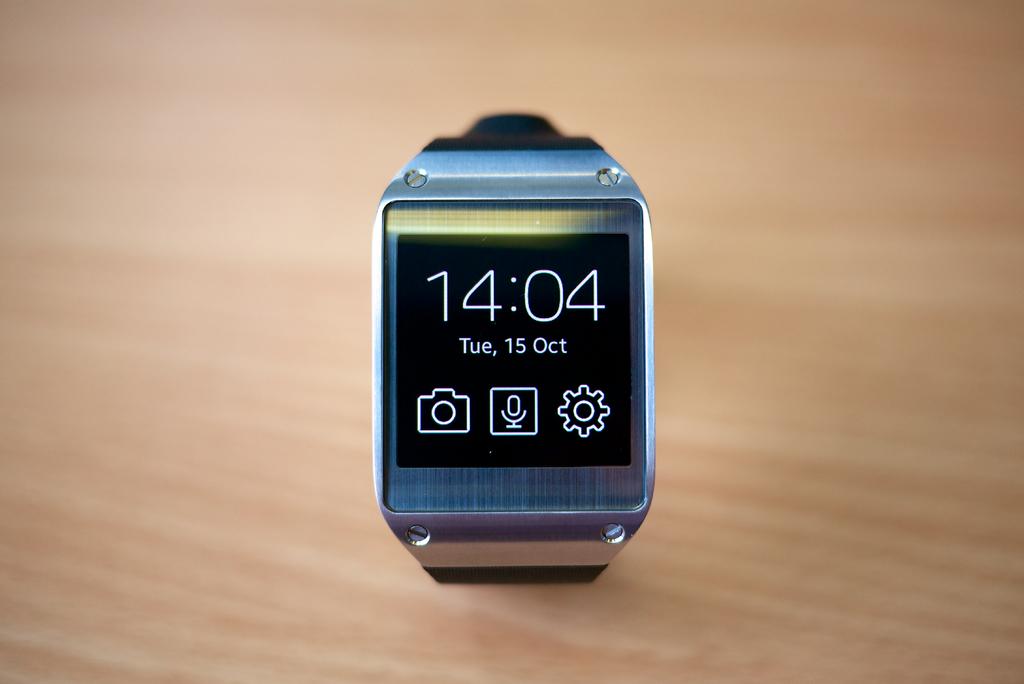What time is it?
Provide a succinct answer. 14:04. What day is it?
Give a very brief answer. Tuesday. 